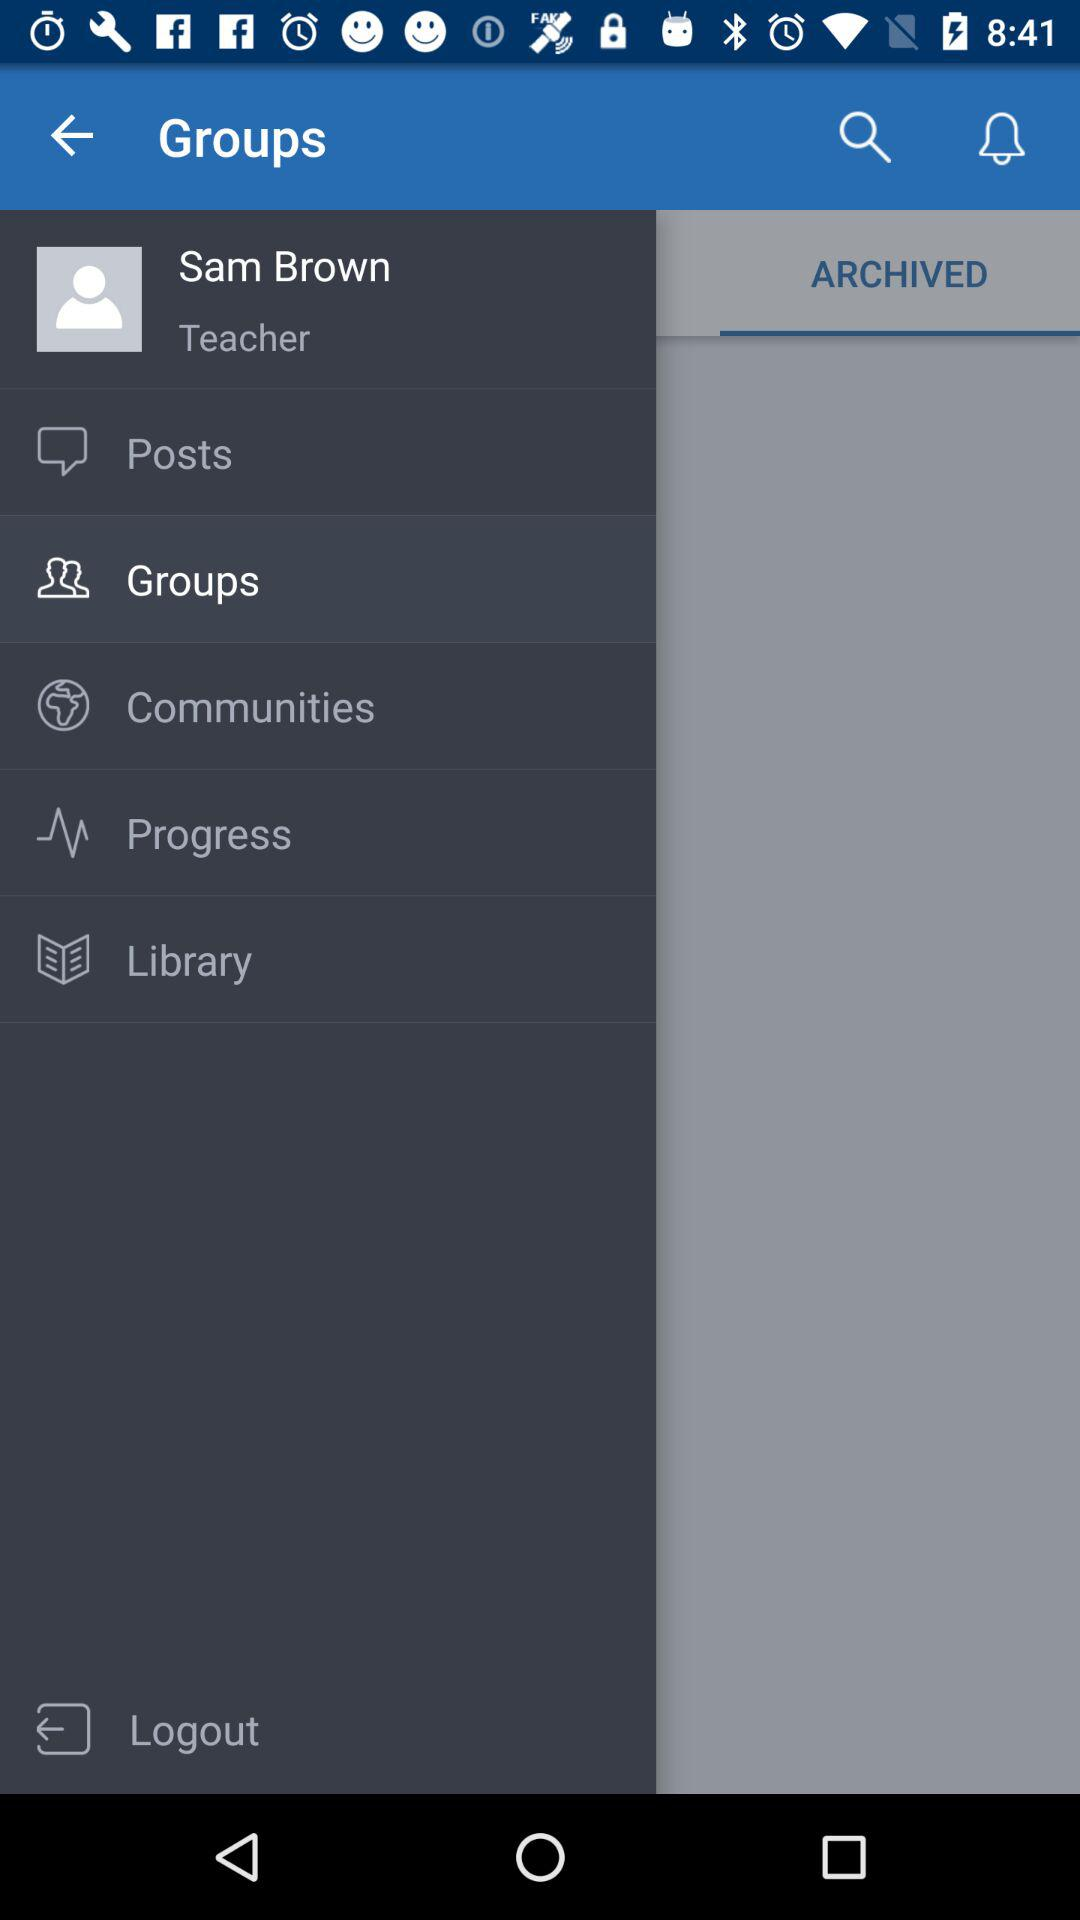Where does Sam Brown work?
When the provided information is insufficient, respond with <no answer>. <no answer> 